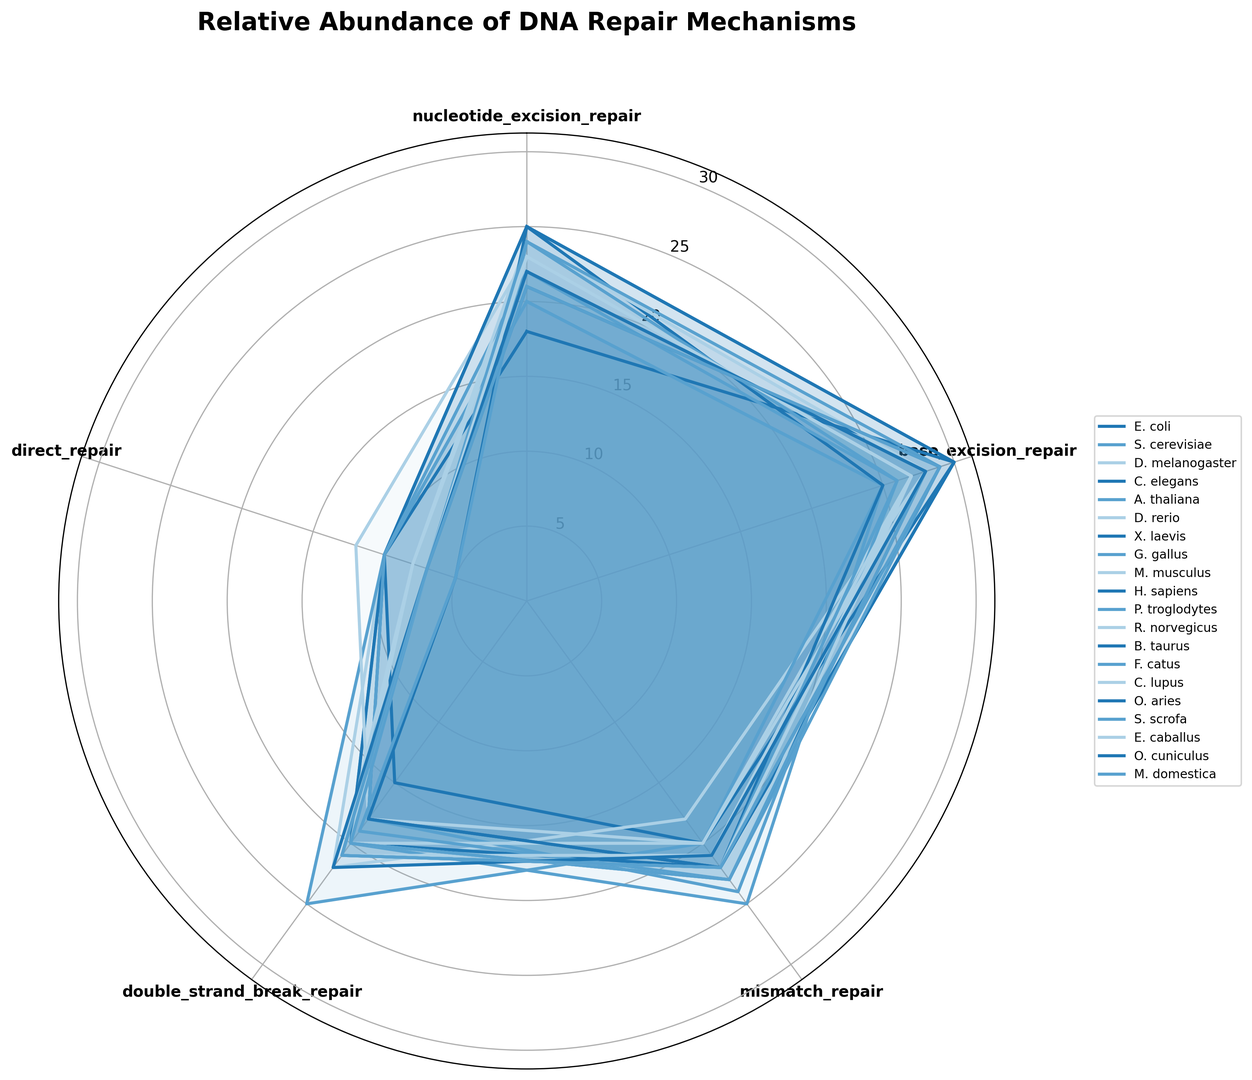Which organism shows the highest relative abundance of nucleotide excision repair? To find the organism with the highest relative abundance of nucleotide excision repair, identify the organism with the longest portion in the corresponding segment of the rose chart for this DNA repair mechanism. H. sapiens and E. coli show the highest value.
Answer: H. sapiens, E. coli Which DNA repair mechanism is most relatively abundant in S. cerevisiae? Look at the segments corresponding to S. cerevisiae and compare the lengths visually to determine which one extends the farthest. Both base excision repair and mismatch repair have the highest values.
Answer: Base excision repair, Mismatch repair Between H. sapiens and M. musculus, which organism has a higher relative abundance of mismatch repair? Compare the lengths of the mismatch repair segments for H. sapiens and M. musculus in the rose chart. H. sapiens has a longer segment.
Answer: H. sapiens What is the average relative abundance of double-strand break repair across all organisms? Sum the values of double-strand break repair for all organisms and divide by the number of organisms. The formula is (15+20+22+20+25+18+18+18+20+18+19+21+20+21+20+21+20+21+21+21)/20.
Answer: 20.3 Which DNA repair mechanism shows the least relative abundance in H. sapiens? Find the smallest segment for H. sapiens in the rose chart. The segment for direct repair is the shortest.
Answer: Direct repair Do E. coli and S. scrofa have similar relative abundances for any DNA repair mechanisms? Compare the relative abundances of each DNA repair mechanism for E. coli and S. scrofa. They have the same values for direct repair and double-strand break repair.
Answer: Direct repair, Double-strand break repair How does the relative abundance of base excision repair in D. melanogaster compare to that in G. gallus? Compare the lengths of the base excision repair segments for both organisms. The lengths for D. melanogaster and G. gallus are measured; G. gallus has a slightly higher value.
Answer: G. gallus What's the difference in the relative abundance of nucleotide excision repair between C. elegans and F. catus? Subtract the relative abundance of nucleotide excision repair in C. elegans from that in F. catus: 24 - 18 = 6.
Answer: 6 What is the sum of relative abundances for all mechanisms in A. thaliana? Add all the values for nucleotide excision repair, base excision repair, mismatch repair, double-strand break repair, and direct repair in A. thaliana: 20 + 25 + 20 + 25 + 10 = 100.
Answer: 100 Which organism shows relatively the most balanced distribution among the five DNA repair mechanisms? Find the organism whose segments in the rose chart are all of relatively similar lengths. S. cerevisiae has the most balanced distribution with almost equal values across all mechanisms.
Answer: S. cerevisiae 